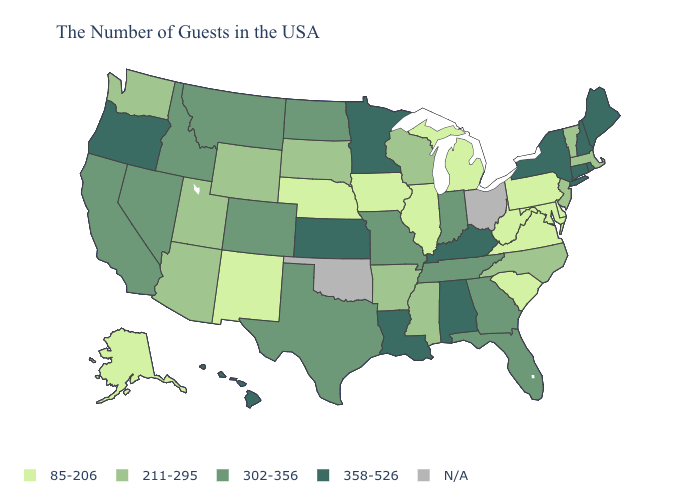What is the highest value in the Northeast ?
Write a very short answer. 358-526. Does the map have missing data?
Be succinct. Yes. Which states have the lowest value in the USA?
Answer briefly. Delaware, Maryland, Pennsylvania, Virginia, South Carolina, West Virginia, Michigan, Illinois, Iowa, Nebraska, New Mexico, Alaska. What is the value of Virginia?
Answer briefly. 85-206. Does Georgia have the lowest value in the USA?
Write a very short answer. No. Is the legend a continuous bar?
Write a very short answer. No. Among the states that border Louisiana , does Texas have the lowest value?
Short answer required. No. Name the states that have a value in the range N/A?
Quick response, please. Ohio, Oklahoma. What is the value of Ohio?
Short answer required. N/A. What is the lowest value in the USA?
Give a very brief answer. 85-206. Does the map have missing data?
Be succinct. Yes. Does Rhode Island have the highest value in the USA?
Write a very short answer. Yes. Name the states that have a value in the range 211-295?
Keep it brief. Massachusetts, Vermont, New Jersey, North Carolina, Wisconsin, Mississippi, Arkansas, South Dakota, Wyoming, Utah, Arizona, Washington. Name the states that have a value in the range 302-356?
Keep it brief. Florida, Georgia, Indiana, Tennessee, Missouri, Texas, North Dakota, Colorado, Montana, Idaho, Nevada, California. Name the states that have a value in the range 358-526?
Keep it brief. Maine, Rhode Island, New Hampshire, Connecticut, New York, Kentucky, Alabama, Louisiana, Minnesota, Kansas, Oregon, Hawaii. 